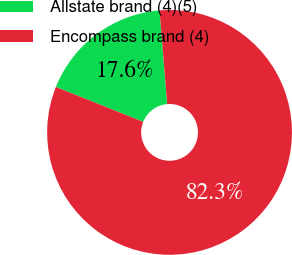Convert chart to OTSL. <chart><loc_0><loc_0><loc_500><loc_500><pie_chart><fcel>Allstate brand (4)(5)<fcel>Encompass brand (4)<nl><fcel>17.65%<fcel>82.35%<nl></chart> 